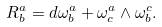<formula> <loc_0><loc_0><loc_500><loc_500>R _ { b } ^ { a } = d \omega _ { b } ^ { a } + \omega _ { c } ^ { a } \wedge \omega _ { b } ^ { c } .</formula> 